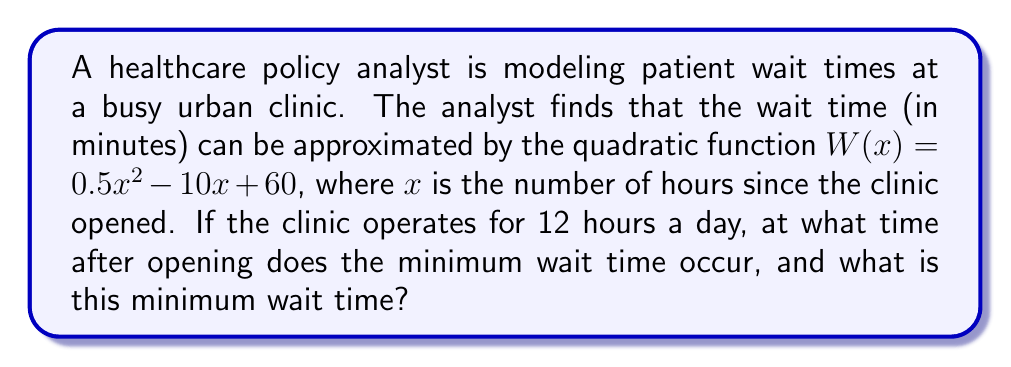Solve this math problem. 1) To find the minimum wait time, we need to find the vertex of the parabola represented by the quadratic function $W(x) = 0.5x^2 - 10x + 60$.

2) For a quadratic function in the form $f(x) = ax^2 + bx + c$, the x-coordinate of the vertex is given by $x = -\frac{b}{2a}$.

3) In this case, $a = 0.5$ and $b = -10$. So:

   $x = -\frac{-10}{2(0.5)} = \frac{10}{1} = 10$

4) This means the minimum wait time occurs 10 hours after the clinic opens.

5) To find the minimum wait time, we substitute $x = 10$ into the original function:

   $W(10) = 0.5(10)^2 - 10(10) + 60$
   $= 0.5(100) - 100 + 60$
   $= 50 - 100 + 60$
   $= 10$

6) Therefore, the minimum wait time is 10 minutes.
Answer: 10 hours after opening; 10 minutes 